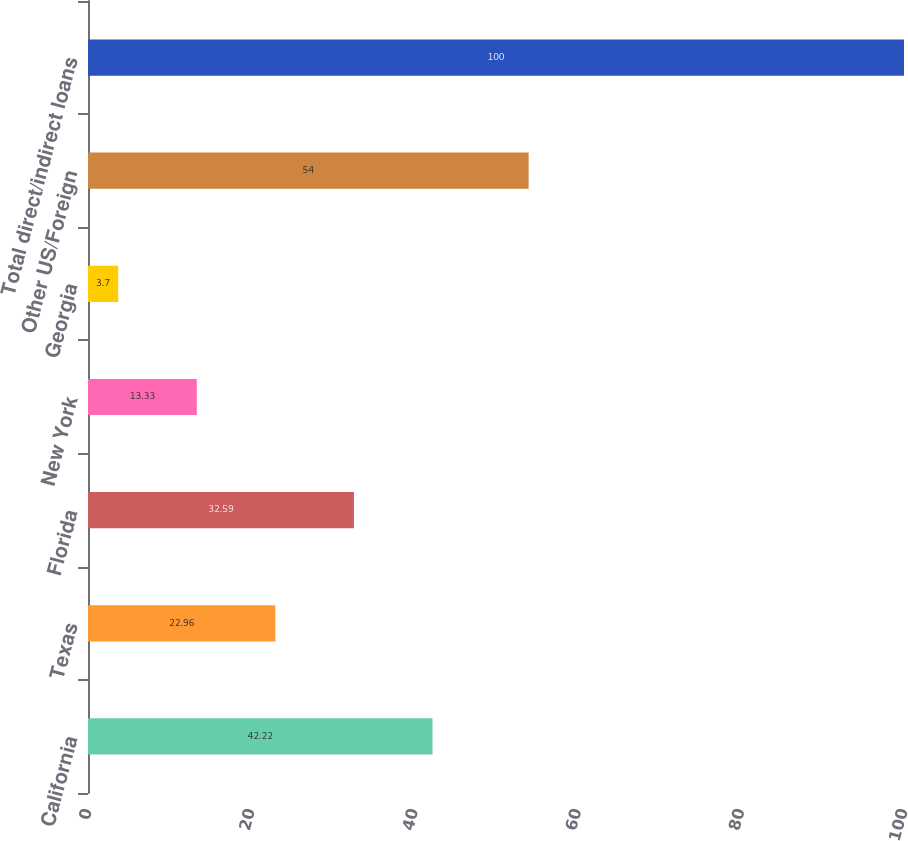Convert chart to OTSL. <chart><loc_0><loc_0><loc_500><loc_500><bar_chart><fcel>California<fcel>Texas<fcel>Florida<fcel>New York<fcel>Georgia<fcel>Other US/Foreign<fcel>Total direct/indirect loans<nl><fcel>42.22<fcel>22.96<fcel>32.59<fcel>13.33<fcel>3.7<fcel>54<fcel>100<nl></chart> 